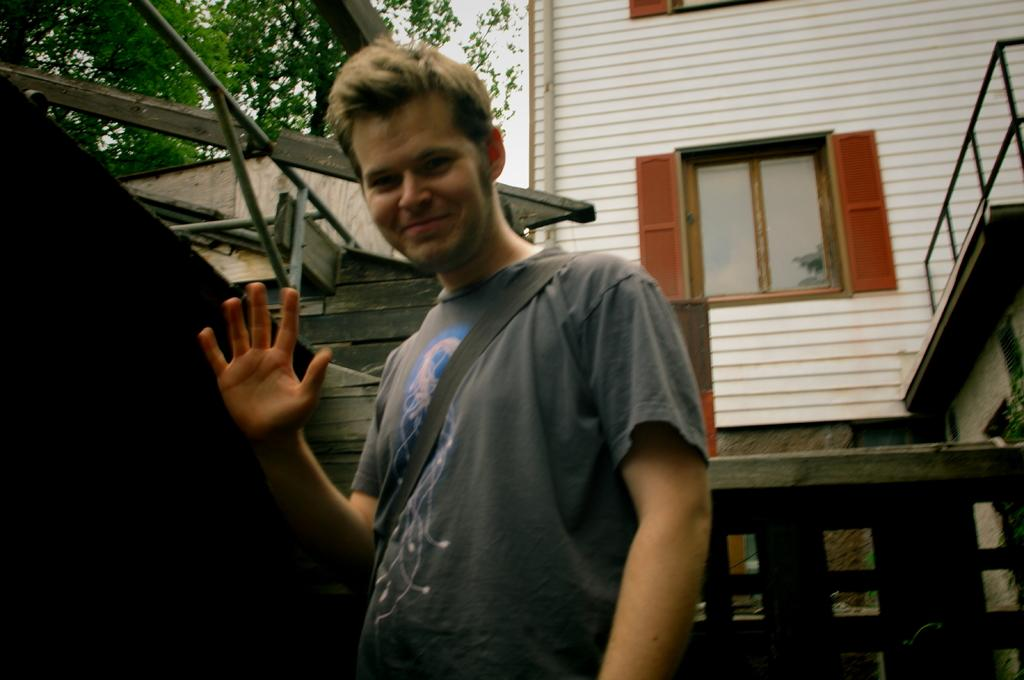What type of structure is visible in the image? There is a building in the image. What other natural element can be seen in the image? There is a tree in the image. Is there anyone present in the image? Yes, a person is standing in the image. What feature of the building is mentioned in the facts? There are windows on the building. What type of steam is coming out of the windows of the building in the image? There is no steam coming out of the windows of the building in the image. What kind of breakfast is the person eating in the image? There is no breakfast visible in the image. 